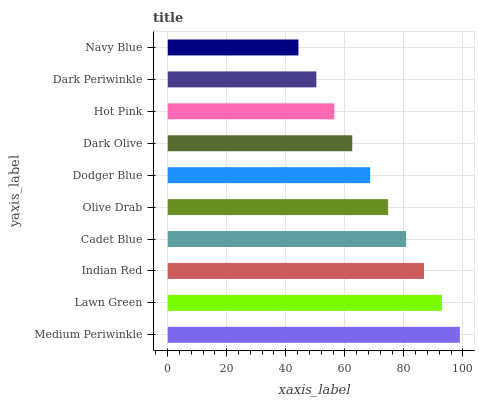Is Navy Blue the minimum?
Answer yes or no. Yes. Is Medium Periwinkle the maximum?
Answer yes or no. Yes. Is Lawn Green the minimum?
Answer yes or no. No. Is Lawn Green the maximum?
Answer yes or no. No. Is Medium Periwinkle greater than Lawn Green?
Answer yes or no. Yes. Is Lawn Green less than Medium Periwinkle?
Answer yes or no. Yes. Is Lawn Green greater than Medium Periwinkle?
Answer yes or no. No. Is Medium Periwinkle less than Lawn Green?
Answer yes or no. No. Is Olive Drab the high median?
Answer yes or no. Yes. Is Dodger Blue the low median?
Answer yes or no. Yes. Is Medium Periwinkle the high median?
Answer yes or no. No. Is Navy Blue the low median?
Answer yes or no. No. 